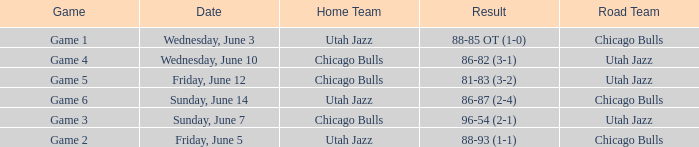Game of game 5 had what result? 81-83 (3-2). 